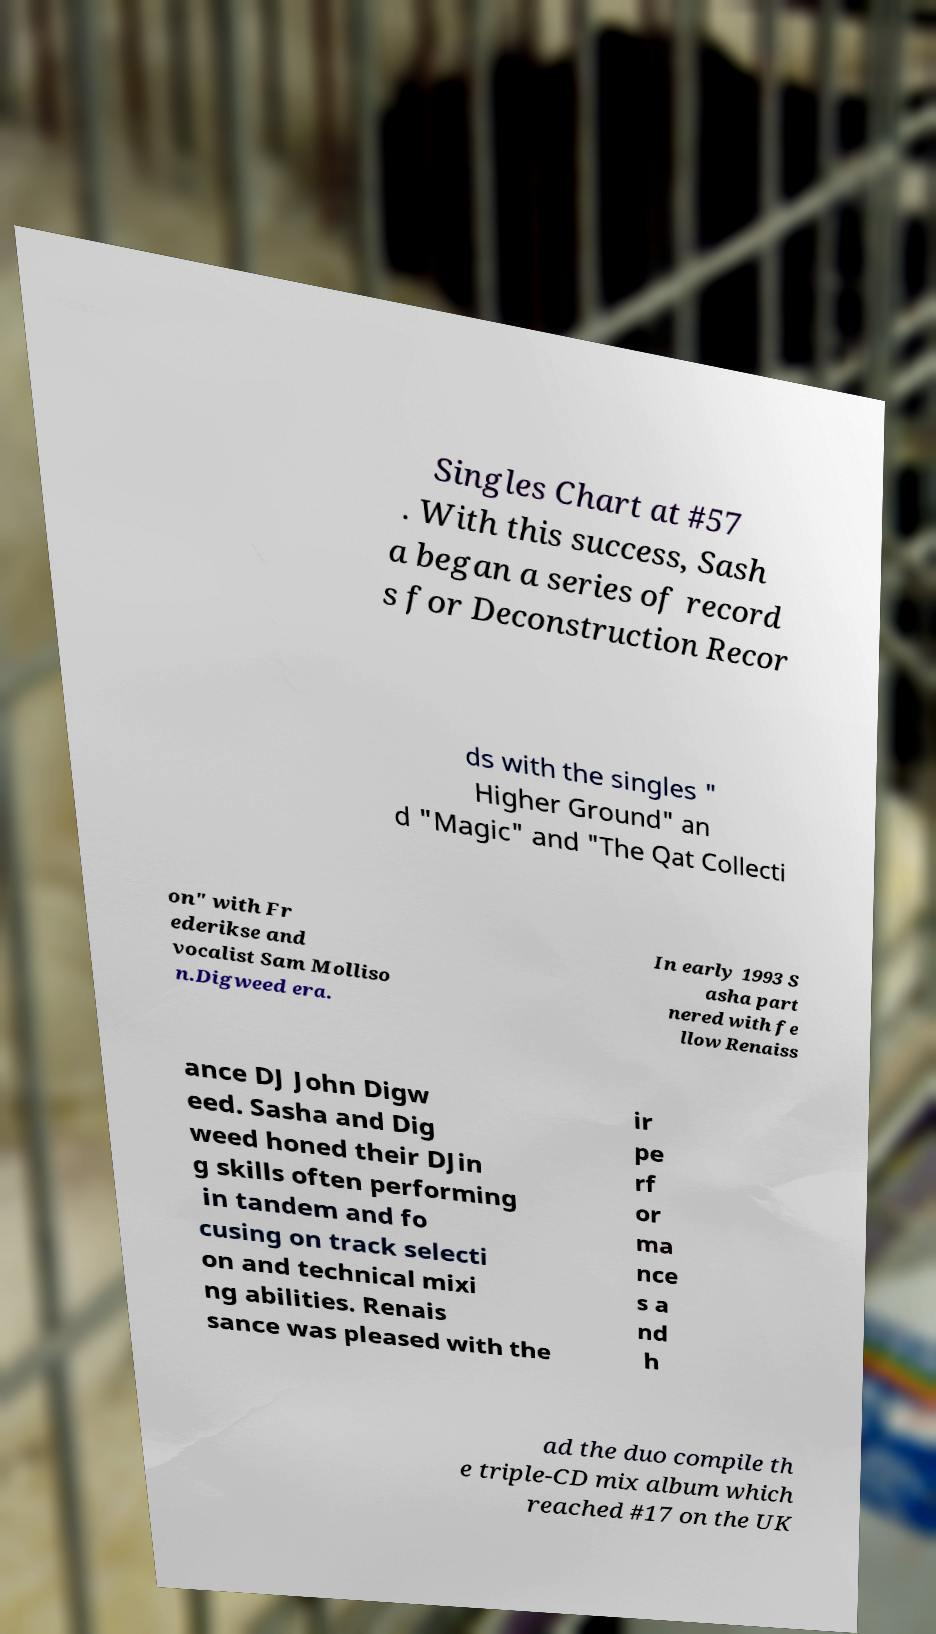Could you assist in decoding the text presented in this image and type it out clearly? Singles Chart at #57 . With this success, Sash a began a series of record s for Deconstruction Recor ds with the singles " Higher Ground" an d "Magic" and "The Qat Collecti on" with Fr ederikse and vocalist Sam Molliso n.Digweed era. In early 1993 S asha part nered with fe llow Renaiss ance DJ John Digw eed. Sasha and Dig weed honed their DJin g skills often performing in tandem and fo cusing on track selecti on and technical mixi ng abilities. Renais sance was pleased with the ir pe rf or ma nce s a nd h ad the duo compile th e triple-CD mix album which reached #17 on the UK 